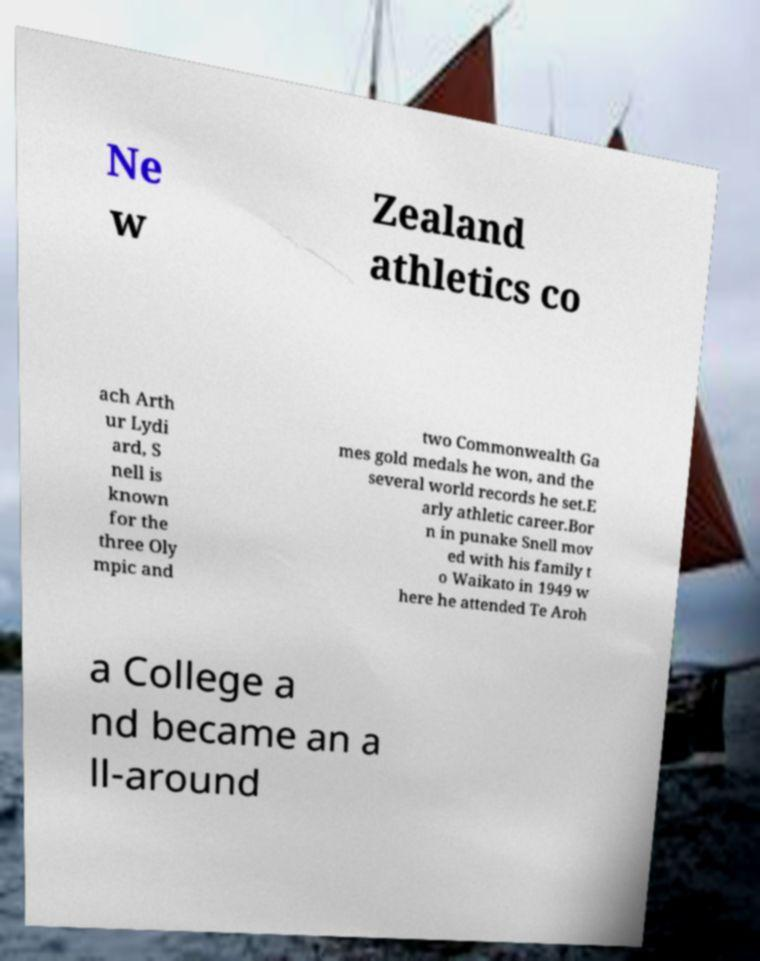Please identify and transcribe the text found in this image. Ne w Zealand athletics co ach Arth ur Lydi ard, S nell is known for the three Oly mpic and two Commonwealth Ga mes gold medals he won, and the several world records he set.E arly athletic career.Bor n in punake Snell mov ed with his family t o Waikato in 1949 w here he attended Te Aroh a College a nd became an a ll-around 